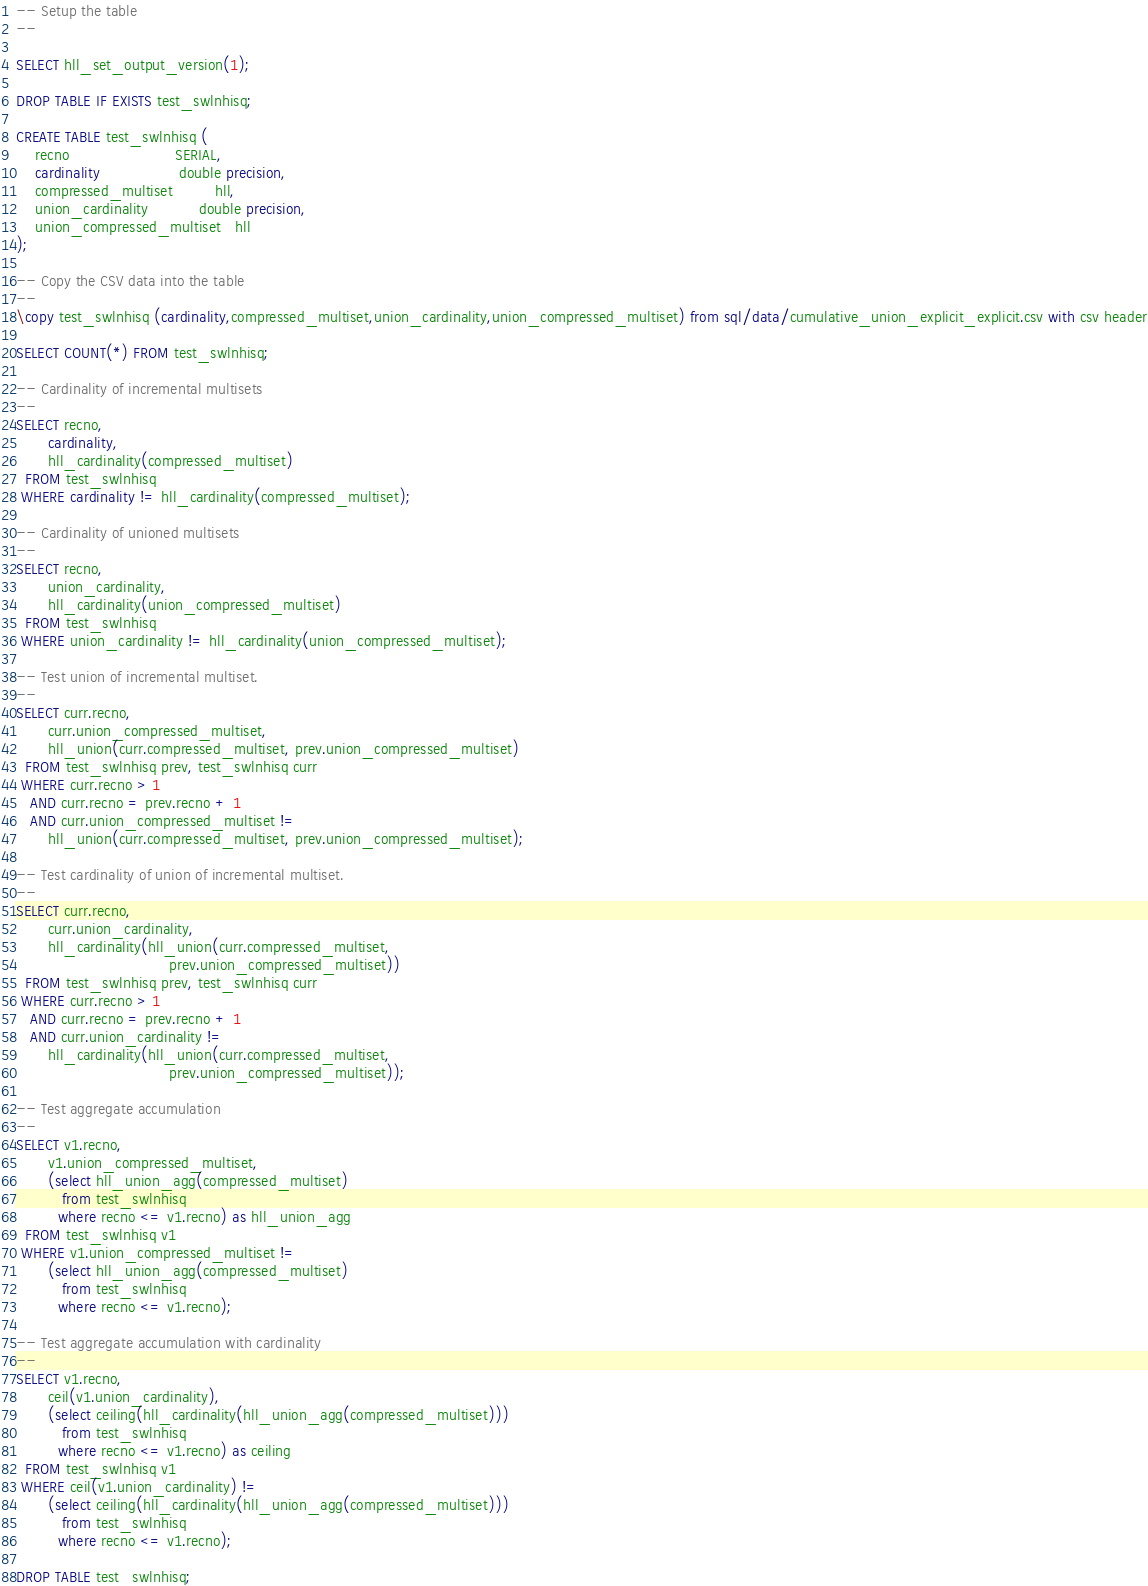Convert code to text. <code><loc_0><loc_0><loc_500><loc_500><_SQL_>-- Setup the table
--

SELECT hll_set_output_version(1);

DROP TABLE IF EXISTS test_swlnhisq;

CREATE TABLE test_swlnhisq (
    recno                       SERIAL,
    cardinality                 double precision,
    compressed_multiset         hll,
    union_cardinality           double precision,
    union_compressed_multiset   hll
);

-- Copy the CSV data into the table
--
\copy test_swlnhisq (cardinality,compressed_multiset,union_cardinality,union_compressed_multiset) from sql/data/cumulative_union_explicit_explicit.csv with csv header

SELECT COUNT(*) FROM test_swlnhisq;

-- Cardinality of incremental multisets
--
SELECT recno,
       cardinality,
       hll_cardinality(compressed_multiset)
  FROM test_swlnhisq
 WHERE cardinality != hll_cardinality(compressed_multiset);

-- Cardinality of unioned multisets
--
SELECT recno,
       union_cardinality,
       hll_cardinality(union_compressed_multiset)
  FROM test_swlnhisq
 WHERE union_cardinality != hll_cardinality(union_compressed_multiset);

-- Test union of incremental multiset.
--
SELECT curr.recno,
       curr.union_compressed_multiset,
       hll_union(curr.compressed_multiset, prev.union_compressed_multiset) 
  FROM test_swlnhisq prev, test_swlnhisq curr
 WHERE curr.recno > 1
   AND curr.recno = prev.recno + 1
   AND curr.union_compressed_multiset != 
       hll_union(curr.compressed_multiset, prev.union_compressed_multiset);

-- Test cardinality of union of incremental multiset.
--
SELECT curr.recno,
       curr.union_cardinality,
       hll_cardinality(hll_union(curr.compressed_multiset,
                                 prev.union_compressed_multiset))
  FROM test_swlnhisq prev, test_swlnhisq curr
 WHERE curr.recno > 1
   AND curr.recno = prev.recno + 1
   AND curr.union_cardinality != 
       hll_cardinality(hll_union(curr.compressed_multiset,
                                 prev.union_compressed_multiset));

-- Test aggregate accumulation
--
SELECT v1.recno,
       v1.union_compressed_multiset,
       (select hll_union_agg(compressed_multiset)
          from test_swlnhisq
         where recno <= v1.recno) as hll_union_agg
  FROM test_swlnhisq v1
 WHERE v1.union_compressed_multiset !=
       (select hll_union_agg(compressed_multiset)
          from test_swlnhisq
         where recno <= v1.recno);

-- Test aggregate accumulation with cardinality
--
SELECT v1.recno,
       ceil(v1.union_cardinality),
       (select ceiling(hll_cardinality(hll_union_agg(compressed_multiset)))
          from test_swlnhisq
         where recno <= v1.recno) as ceiling
  FROM test_swlnhisq v1
 WHERE ceil(v1.union_cardinality) !=
       (select ceiling(hll_cardinality(hll_union_agg(compressed_multiset)))
          from test_swlnhisq
         where recno <= v1.recno);

DROP TABLE test_swlnhisq;

</code> 